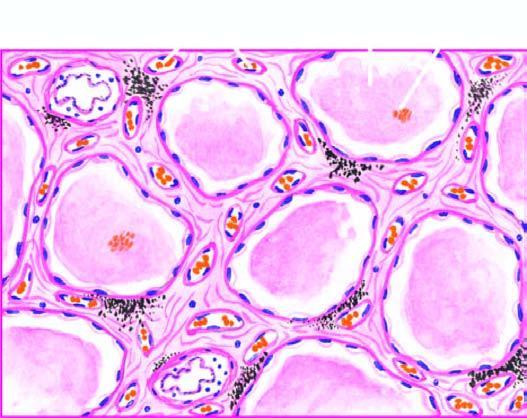what contain eosinophilic, granular, homogeneous and pink proteinaceous oedema fluid along with some rbcs and inflammatory cells?
Answer the question using a single word or phrase. The alveolar spaces 